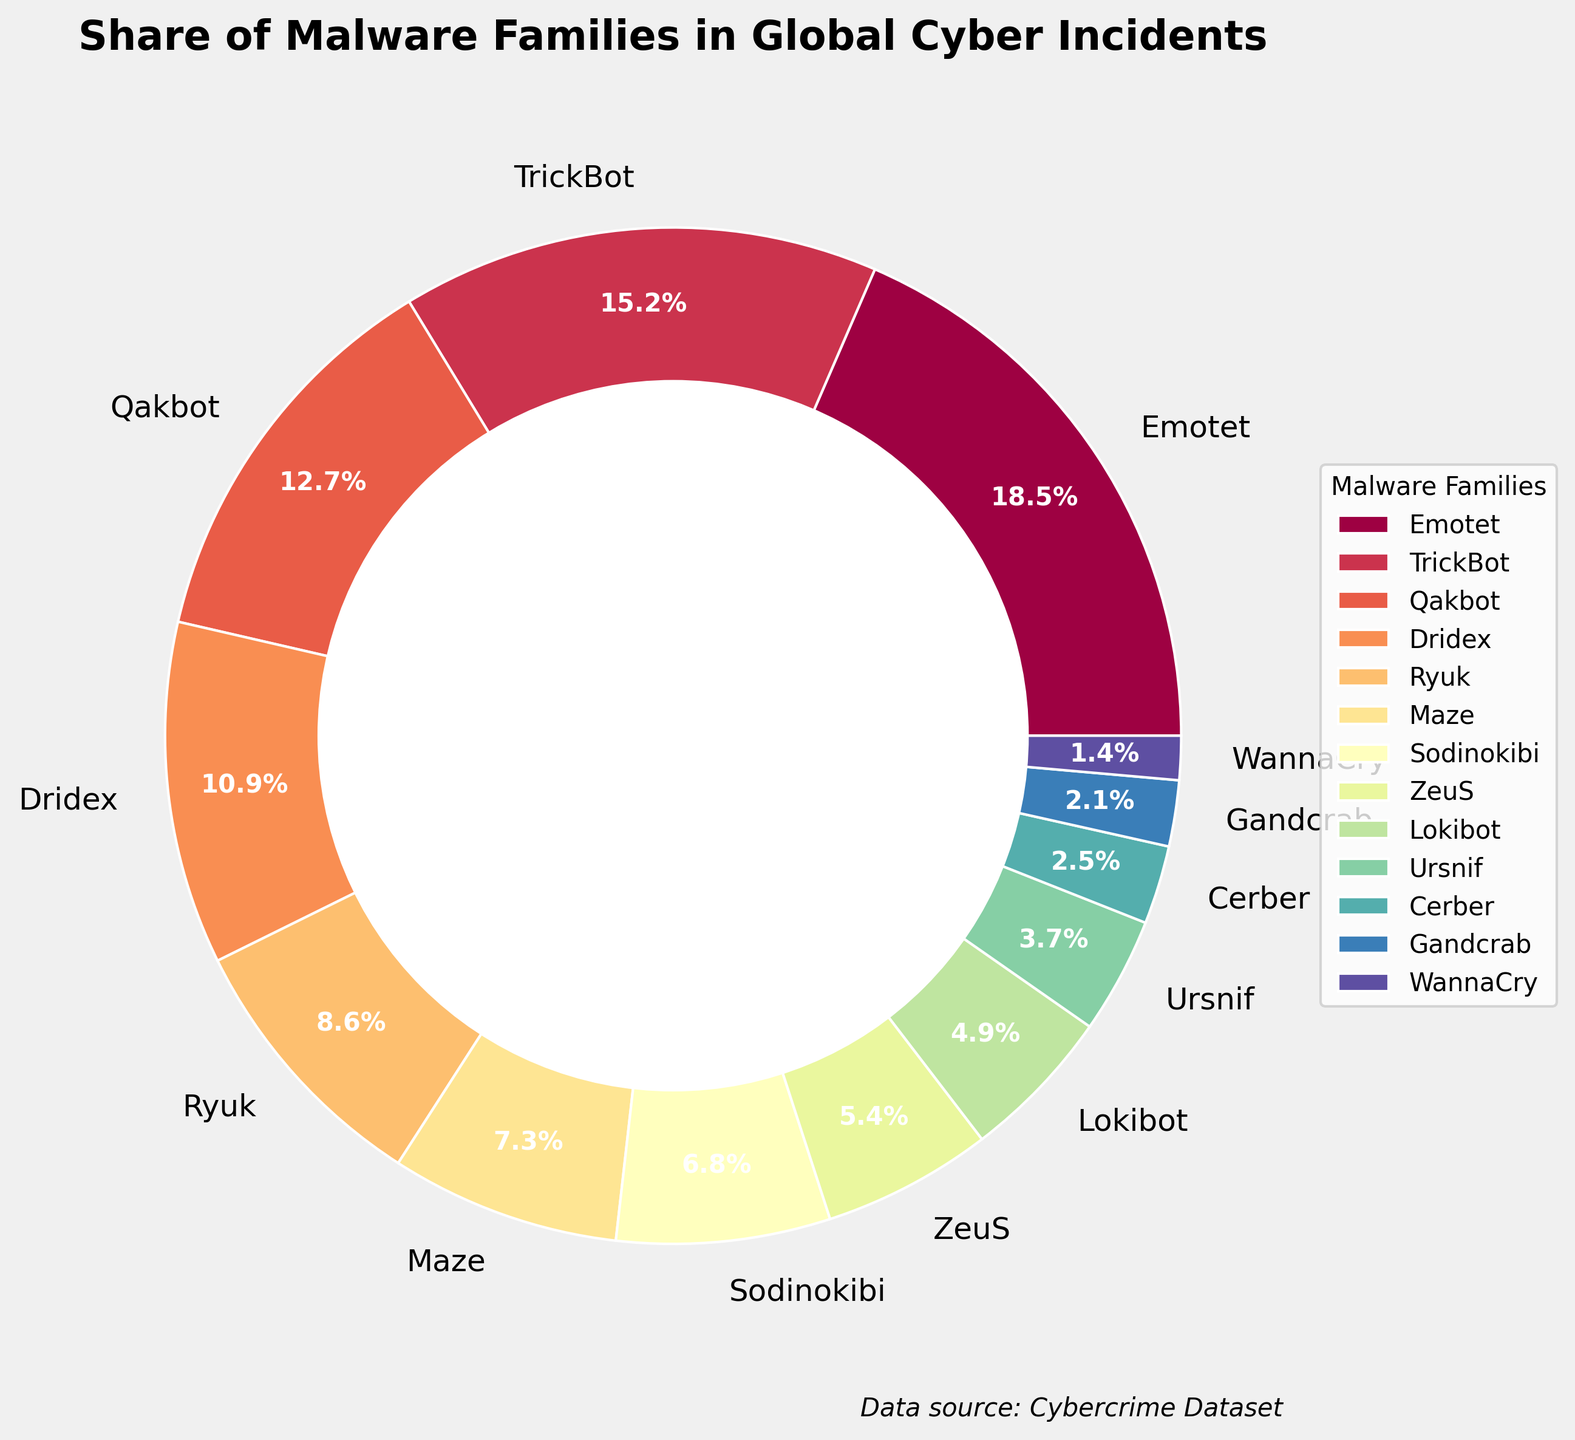Which malware family has the highest percentage share? By inspection, the largest segment in the pie chart is labeled "Emotet" with 18.5%.
Answer: Emotet Which two malware families contribute to a combined percentage of more than 30%? Inspecting the chart, Emotet (18.5%) and TrickBot (15.2%) are the largest segments. Adding these percentages, 18.5% + 15.2% = 33.7%, which is greater than 30%.
Answer: Emotet and TrickBot What is the total percentage share of Dridex and Qakbot? By adding the percentages of Dridex (10.9%) and Qakbot (12.7%), we get 10.9% + 12.7% = 23.6%.
Answer: 23.6% Which malware family has a lower percentage share, Maze or Sodinokibi? The pie chart shows Maze with 7.3% and Sodinokibi with 6.8%. Since 6.8% is less than 7.3%, Sodinokibi has a lower percentage share.
Answer: Sodinokibi Which malware family slices are visually closest in size? Inspecting the pie chart, the sizes of Ryuk (8.6%) and Maze (7.3%) slices are visually close.
Answer: Ryuk and Maze What is the combined percentage of the three least prevalent malware families? The three smallest percentages in the chart are WannaCry (1.4%), Gandcrab (2.1%), and Cerber (2.5%). Summing these, we get 1.4% + 2.1% + 2.5% = 6.0%.
Answer: 6.0% How many malware families have a share of more than 10%? The pie chart shows Emotet (18.5%), TrickBot (15.2%), and Qakbot (12.7%) each have shares above 10%. Counting these, we get three families.
Answer: 3 What is the mean percentage share of the bottom five malware families? The percentages for the bottom five malware families are ZeuS (5.4%), Lokibot (4.9%), Ursnif (3.7%), Cerber (2.5%), and Gandcrab (2.1%). Calculating the mean, (5.4% + 4.9% + 3.7% + 2.5% + 2.1%) / 5 = 3.72%.
Answer: 3.72% What percentage difference is there between the highest and lowest contributing malware families? The highest percentage is Emotet (18.5%), and the lowest is WannaCry (1.4%). The difference is 18.5% - 1.4% = 17.1%.
Answer: 17.1% What does the largest section of the chart represent? The largest section of the pie chart is labeled "Emotet" with 18.5%, indicating its share among global cyber incidents.
Answer: Emotet's share 